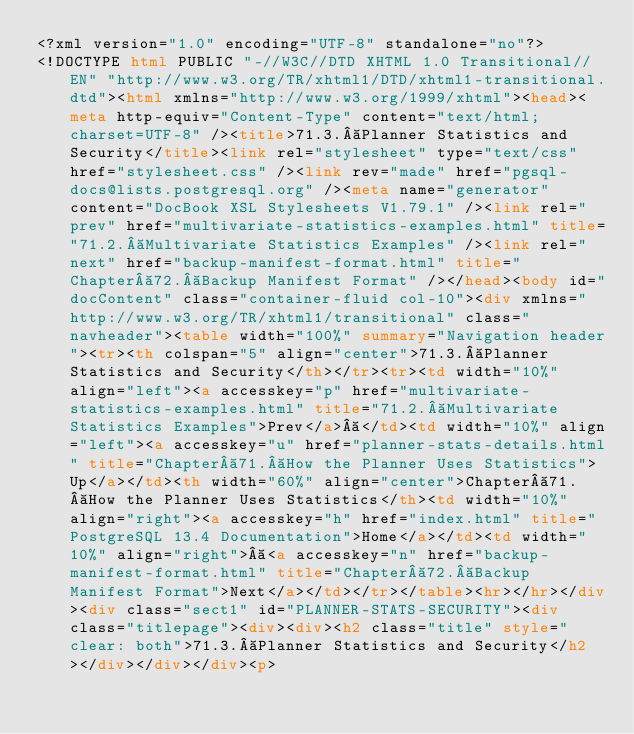Convert code to text. <code><loc_0><loc_0><loc_500><loc_500><_HTML_><?xml version="1.0" encoding="UTF-8" standalone="no"?>
<!DOCTYPE html PUBLIC "-//W3C//DTD XHTML 1.0 Transitional//EN" "http://www.w3.org/TR/xhtml1/DTD/xhtml1-transitional.dtd"><html xmlns="http://www.w3.org/1999/xhtml"><head><meta http-equiv="Content-Type" content="text/html; charset=UTF-8" /><title>71.3. Planner Statistics and Security</title><link rel="stylesheet" type="text/css" href="stylesheet.css" /><link rev="made" href="pgsql-docs@lists.postgresql.org" /><meta name="generator" content="DocBook XSL Stylesheets V1.79.1" /><link rel="prev" href="multivariate-statistics-examples.html" title="71.2. Multivariate Statistics Examples" /><link rel="next" href="backup-manifest-format.html" title="Chapter 72. Backup Manifest Format" /></head><body id="docContent" class="container-fluid col-10"><div xmlns="http://www.w3.org/TR/xhtml1/transitional" class="navheader"><table width="100%" summary="Navigation header"><tr><th colspan="5" align="center">71.3. Planner Statistics and Security</th></tr><tr><td width="10%" align="left"><a accesskey="p" href="multivariate-statistics-examples.html" title="71.2. Multivariate Statistics Examples">Prev</a> </td><td width="10%" align="left"><a accesskey="u" href="planner-stats-details.html" title="Chapter 71. How the Planner Uses Statistics">Up</a></td><th width="60%" align="center">Chapter 71. How the Planner Uses Statistics</th><td width="10%" align="right"><a accesskey="h" href="index.html" title="PostgreSQL 13.4 Documentation">Home</a></td><td width="10%" align="right"> <a accesskey="n" href="backup-manifest-format.html" title="Chapter 72. Backup Manifest Format">Next</a></td></tr></table><hr></hr></div><div class="sect1" id="PLANNER-STATS-SECURITY"><div class="titlepage"><div><div><h2 class="title" style="clear: both">71.3. Planner Statistics and Security</h2></div></div></div><p></code> 